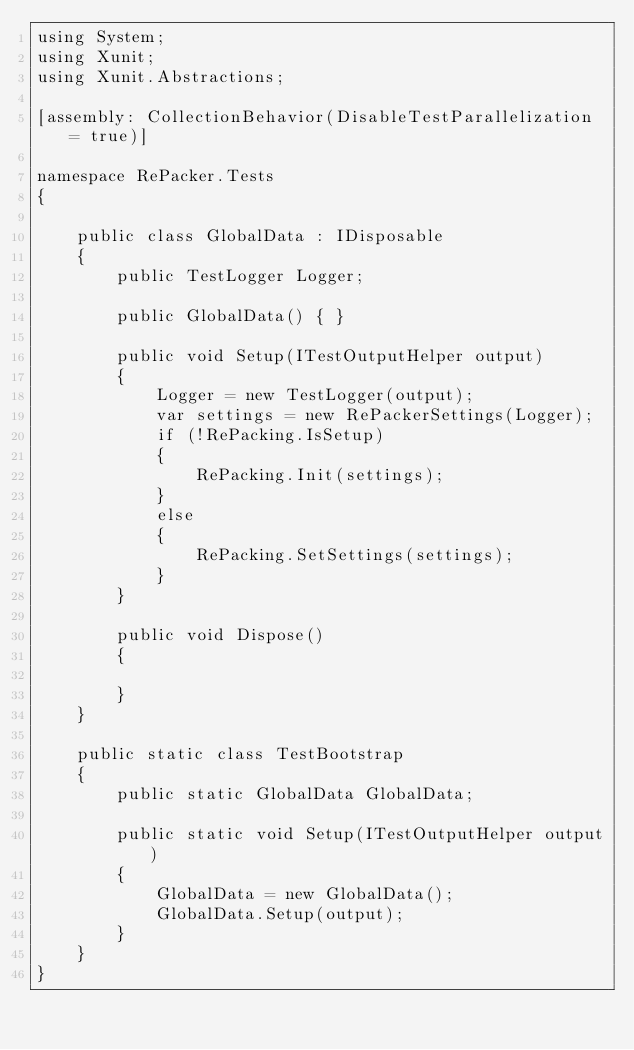Convert code to text. <code><loc_0><loc_0><loc_500><loc_500><_C#_>using System;
using Xunit;
using Xunit.Abstractions;

[assembly: CollectionBehavior(DisableTestParallelization = true)]

namespace RePacker.Tests
{

    public class GlobalData : IDisposable
    {
        public TestLogger Logger;

        public GlobalData() { }

        public void Setup(ITestOutputHelper output)
        {
            Logger = new TestLogger(output);
            var settings = new RePackerSettings(Logger);
            if (!RePacking.IsSetup)
            {
                RePacking.Init(settings);
            }
            else
            {
                RePacking.SetSettings(settings);
            }
        }

        public void Dispose()
        {

        }
    }

    public static class TestBootstrap
    {
        public static GlobalData GlobalData;

        public static void Setup(ITestOutputHelper output)
        {
            GlobalData = new GlobalData();
            GlobalData.Setup(output);
        }
    }
}</code> 